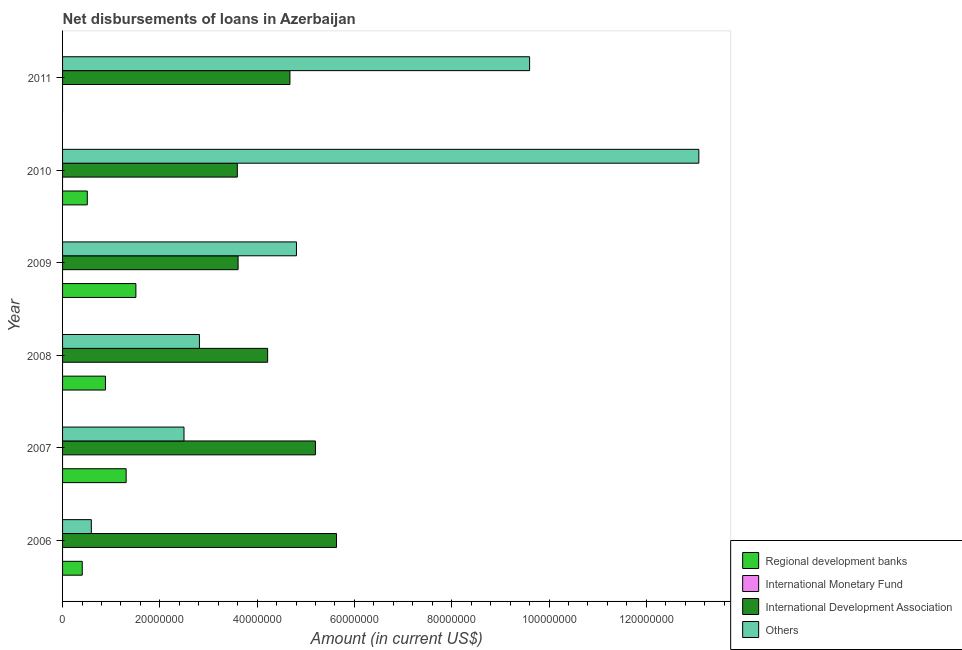How many different coloured bars are there?
Make the answer very short. 3. How many groups of bars are there?
Your answer should be compact. 6. Are the number of bars on each tick of the Y-axis equal?
Offer a terse response. No. In how many cases, is the number of bars for a given year not equal to the number of legend labels?
Keep it short and to the point. 6. What is the amount of loan disimbursed by regional development banks in 2006?
Provide a succinct answer. 4.04e+06. Across all years, what is the maximum amount of loan disimbursed by other organisations?
Provide a short and direct response. 1.31e+08. Across all years, what is the minimum amount of loan disimbursed by other organisations?
Provide a succinct answer. 5.91e+06. What is the total amount of loan disimbursed by regional development banks in the graph?
Keep it short and to the point. 4.61e+07. What is the difference between the amount of loan disimbursed by international development association in 2007 and that in 2011?
Make the answer very short. 5.24e+06. What is the difference between the amount of loan disimbursed by regional development banks in 2010 and the amount of loan disimbursed by international development association in 2011?
Provide a succinct answer. -4.17e+07. What is the average amount of loan disimbursed by other organisations per year?
Ensure brevity in your answer.  5.56e+07. In the year 2009, what is the difference between the amount of loan disimbursed by international development association and amount of loan disimbursed by other organisations?
Ensure brevity in your answer.  -1.20e+07. What is the ratio of the amount of loan disimbursed by other organisations in 2007 to that in 2011?
Your answer should be compact. 0.26. Is the amount of loan disimbursed by other organisations in 2006 less than that in 2007?
Offer a very short reply. Yes. Is the difference between the amount of loan disimbursed by international development association in 2006 and 2008 greater than the difference between the amount of loan disimbursed by regional development banks in 2006 and 2008?
Offer a very short reply. Yes. What is the difference between the highest and the second highest amount of loan disimbursed by international development association?
Make the answer very short. 4.33e+06. What is the difference between the highest and the lowest amount of loan disimbursed by other organisations?
Your answer should be very brief. 1.25e+08. Is it the case that in every year, the sum of the amount of loan disimbursed by regional development banks and amount of loan disimbursed by international monetary fund is greater than the amount of loan disimbursed by international development association?
Provide a succinct answer. No. How many years are there in the graph?
Provide a short and direct response. 6. What is the difference between two consecutive major ticks on the X-axis?
Your answer should be very brief. 2.00e+07. Does the graph contain any zero values?
Make the answer very short. Yes. Does the graph contain grids?
Offer a terse response. No. Where does the legend appear in the graph?
Keep it short and to the point. Bottom right. How many legend labels are there?
Ensure brevity in your answer.  4. What is the title of the graph?
Your response must be concise. Net disbursements of loans in Azerbaijan. Does "Industry" appear as one of the legend labels in the graph?
Provide a succinct answer. No. What is the label or title of the X-axis?
Ensure brevity in your answer.  Amount (in current US$). What is the label or title of the Y-axis?
Your answer should be compact. Year. What is the Amount (in current US$) in Regional development banks in 2006?
Keep it short and to the point. 4.04e+06. What is the Amount (in current US$) of International Development Association in 2006?
Offer a terse response. 5.63e+07. What is the Amount (in current US$) of Others in 2006?
Give a very brief answer. 5.91e+06. What is the Amount (in current US$) of Regional development banks in 2007?
Keep it short and to the point. 1.31e+07. What is the Amount (in current US$) in International Monetary Fund in 2007?
Provide a succinct answer. 0. What is the Amount (in current US$) in International Development Association in 2007?
Keep it short and to the point. 5.20e+07. What is the Amount (in current US$) in Others in 2007?
Your answer should be compact. 2.50e+07. What is the Amount (in current US$) of Regional development banks in 2008?
Offer a very short reply. 8.81e+06. What is the Amount (in current US$) of International Development Association in 2008?
Provide a short and direct response. 4.22e+07. What is the Amount (in current US$) in Others in 2008?
Provide a succinct answer. 2.81e+07. What is the Amount (in current US$) of Regional development banks in 2009?
Provide a succinct answer. 1.51e+07. What is the Amount (in current US$) in International Development Association in 2009?
Keep it short and to the point. 3.61e+07. What is the Amount (in current US$) in Others in 2009?
Provide a succinct answer. 4.81e+07. What is the Amount (in current US$) of Regional development banks in 2010?
Give a very brief answer. 5.08e+06. What is the Amount (in current US$) in International Development Association in 2010?
Your answer should be very brief. 3.59e+07. What is the Amount (in current US$) in Others in 2010?
Keep it short and to the point. 1.31e+08. What is the Amount (in current US$) in International Development Association in 2011?
Give a very brief answer. 4.67e+07. What is the Amount (in current US$) of Others in 2011?
Offer a terse response. 9.60e+07. Across all years, what is the maximum Amount (in current US$) in Regional development banks?
Provide a short and direct response. 1.51e+07. Across all years, what is the maximum Amount (in current US$) in International Development Association?
Make the answer very short. 5.63e+07. Across all years, what is the maximum Amount (in current US$) in Others?
Ensure brevity in your answer.  1.31e+08. Across all years, what is the minimum Amount (in current US$) in Regional development banks?
Keep it short and to the point. 0. Across all years, what is the minimum Amount (in current US$) of International Development Association?
Make the answer very short. 3.59e+07. Across all years, what is the minimum Amount (in current US$) in Others?
Ensure brevity in your answer.  5.91e+06. What is the total Amount (in current US$) in Regional development banks in the graph?
Provide a short and direct response. 4.61e+07. What is the total Amount (in current US$) of International Development Association in the graph?
Make the answer very short. 2.69e+08. What is the total Amount (in current US$) of Others in the graph?
Your answer should be compact. 3.34e+08. What is the difference between the Amount (in current US$) in Regional development banks in 2006 and that in 2007?
Ensure brevity in your answer.  -9.02e+06. What is the difference between the Amount (in current US$) of International Development Association in 2006 and that in 2007?
Your answer should be very brief. 4.33e+06. What is the difference between the Amount (in current US$) in Others in 2006 and that in 2007?
Ensure brevity in your answer.  -1.90e+07. What is the difference between the Amount (in current US$) of Regional development banks in 2006 and that in 2008?
Provide a short and direct response. -4.77e+06. What is the difference between the Amount (in current US$) of International Development Association in 2006 and that in 2008?
Your answer should be compact. 1.42e+07. What is the difference between the Amount (in current US$) in Others in 2006 and that in 2008?
Make the answer very short. -2.22e+07. What is the difference between the Amount (in current US$) of Regional development banks in 2006 and that in 2009?
Make the answer very short. -1.10e+07. What is the difference between the Amount (in current US$) of International Development Association in 2006 and that in 2009?
Give a very brief answer. 2.02e+07. What is the difference between the Amount (in current US$) of Others in 2006 and that in 2009?
Provide a succinct answer. -4.22e+07. What is the difference between the Amount (in current US$) of Regional development banks in 2006 and that in 2010?
Your answer should be compact. -1.04e+06. What is the difference between the Amount (in current US$) in International Development Association in 2006 and that in 2010?
Offer a very short reply. 2.04e+07. What is the difference between the Amount (in current US$) in Others in 2006 and that in 2010?
Provide a succinct answer. -1.25e+08. What is the difference between the Amount (in current US$) of International Development Association in 2006 and that in 2011?
Offer a terse response. 9.57e+06. What is the difference between the Amount (in current US$) of Others in 2006 and that in 2011?
Your answer should be compact. -9.01e+07. What is the difference between the Amount (in current US$) in Regional development banks in 2007 and that in 2008?
Offer a very short reply. 4.26e+06. What is the difference between the Amount (in current US$) of International Development Association in 2007 and that in 2008?
Your response must be concise. 9.82e+06. What is the difference between the Amount (in current US$) of Others in 2007 and that in 2008?
Your answer should be very brief. -3.17e+06. What is the difference between the Amount (in current US$) in Regional development banks in 2007 and that in 2009?
Provide a succinct answer. -2.00e+06. What is the difference between the Amount (in current US$) in International Development Association in 2007 and that in 2009?
Provide a succinct answer. 1.59e+07. What is the difference between the Amount (in current US$) in Others in 2007 and that in 2009?
Your answer should be very brief. -2.31e+07. What is the difference between the Amount (in current US$) of Regional development banks in 2007 and that in 2010?
Provide a succinct answer. 7.98e+06. What is the difference between the Amount (in current US$) of International Development Association in 2007 and that in 2010?
Keep it short and to the point. 1.61e+07. What is the difference between the Amount (in current US$) in Others in 2007 and that in 2010?
Your response must be concise. -1.06e+08. What is the difference between the Amount (in current US$) in International Development Association in 2007 and that in 2011?
Your answer should be compact. 5.24e+06. What is the difference between the Amount (in current US$) in Others in 2007 and that in 2011?
Give a very brief answer. -7.10e+07. What is the difference between the Amount (in current US$) in Regional development banks in 2008 and that in 2009?
Provide a short and direct response. -6.26e+06. What is the difference between the Amount (in current US$) in International Development Association in 2008 and that in 2009?
Your response must be concise. 6.08e+06. What is the difference between the Amount (in current US$) of Others in 2008 and that in 2009?
Offer a terse response. -1.99e+07. What is the difference between the Amount (in current US$) of Regional development banks in 2008 and that in 2010?
Offer a terse response. 3.73e+06. What is the difference between the Amount (in current US$) in International Development Association in 2008 and that in 2010?
Give a very brief answer. 6.23e+06. What is the difference between the Amount (in current US$) of Others in 2008 and that in 2010?
Make the answer very short. -1.03e+08. What is the difference between the Amount (in current US$) of International Development Association in 2008 and that in 2011?
Give a very brief answer. -4.58e+06. What is the difference between the Amount (in current US$) in Others in 2008 and that in 2011?
Keep it short and to the point. -6.79e+07. What is the difference between the Amount (in current US$) in Regional development banks in 2009 and that in 2010?
Make the answer very short. 9.99e+06. What is the difference between the Amount (in current US$) in International Development Association in 2009 and that in 2010?
Your response must be concise. 1.56e+05. What is the difference between the Amount (in current US$) of Others in 2009 and that in 2010?
Provide a short and direct response. -8.27e+07. What is the difference between the Amount (in current US$) in International Development Association in 2009 and that in 2011?
Give a very brief answer. -1.07e+07. What is the difference between the Amount (in current US$) of Others in 2009 and that in 2011?
Keep it short and to the point. -4.79e+07. What is the difference between the Amount (in current US$) of International Development Association in 2010 and that in 2011?
Keep it short and to the point. -1.08e+07. What is the difference between the Amount (in current US$) in Others in 2010 and that in 2011?
Keep it short and to the point. 3.48e+07. What is the difference between the Amount (in current US$) of Regional development banks in 2006 and the Amount (in current US$) of International Development Association in 2007?
Your answer should be compact. -4.79e+07. What is the difference between the Amount (in current US$) in Regional development banks in 2006 and the Amount (in current US$) in Others in 2007?
Keep it short and to the point. -2.09e+07. What is the difference between the Amount (in current US$) of International Development Association in 2006 and the Amount (in current US$) of Others in 2007?
Your answer should be very brief. 3.14e+07. What is the difference between the Amount (in current US$) of Regional development banks in 2006 and the Amount (in current US$) of International Development Association in 2008?
Make the answer very short. -3.81e+07. What is the difference between the Amount (in current US$) in Regional development banks in 2006 and the Amount (in current US$) in Others in 2008?
Offer a very short reply. -2.41e+07. What is the difference between the Amount (in current US$) in International Development Association in 2006 and the Amount (in current US$) in Others in 2008?
Provide a succinct answer. 2.82e+07. What is the difference between the Amount (in current US$) in Regional development banks in 2006 and the Amount (in current US$) in International Development Association in 2009?
Your answer should be very brief. -3.20e+07. What is the difference between the Amount (in current US$) of Regional development banks in 2006 and the Amount (in current US$) of Others in 2009?
Your response must be concise. -4.40e+07. What is the difference between the Amount (in current US$) of International Development Association in 2006 and the Amount (in current US$) of Others in 2009?
Provide a short and direct response. 8.23e+06. What is the difference between the Amount (in current US$) of Regional development banks in 2006 and the Amount (in current US$) of International Development Association in 2010?
Provide a short and direct response. -3.19e+07. What is the difference between the Amount (in current US$) in Regional development banks in 2006 and the Amount (in current US$) in Others in 2010?
Provide a short and direct response. -1.27e+08. What is the difference between the Amount (in current US$) in International Development Association in 2006 and the Amount (in current US$) in Others in 2010?
Keep it short and to the point. -7.45e+07. What is the difference between the Amount (in current US$) of Regional development banks in 2006 and the Amount (in current US$) of International Development Association in 2011?
Give a very brief answer. -4.27e+07. What is the difference between the Amount (in current US$) in Regional development banks in 2006 and the Amount (in current US$) in Others in 2011?
Provide a short and direct response. -9.20e+07. What is the difference between the Amount (in current US$) in International Development Association in 2006 and the Amount (in current US$) in Others in 2011?
Provide a succinct answer. -3.97e+07. What is the difference between the Amount (in current US$) of Regional development banks in 2007 and the Amount (in current US$) of International Development Association in 2008?
Offer a terse response. -2.91e+07. What is the difference between the Amount (in current US$) in Regional development banks in 2007 and the Amount (in current US$) in Others in 2008?
Make the answer very short. -1.51e+07. What is the difference between the Amount (in current US$) of International Development Association in 2007 and the Amount (in current US$) of Others in 2008?
Your answer should be very brief. 2.38e+07. What is the difference between the Amount (in current US$) in Regional development banks in 2007 and the Amount (in current US$) in International Development Association in 2009?
Ensure brevity in your answer.  -2.30e+07. What is the difference between the Amount (in current US$) in Regional development banks in 2007 and the Amount (in current US$) in Others in 2009?
Ensure brevity in your answer.  -3.50e+07. What is the difference between the Amount (in current US$) of International Development Association in 2007 and the Amount (in current US$) of Others in 2009?
Make the answer very short. 3.90e+06. What is the difference between the Amount (in current US$) of Regional development banks in 2007 and the Amount (in current US$) of International Development Association in 2010?
Provide a short and direct response. -2.29e+07. What is the difference between the Amount (in current US$) of Regional development banks in 2007 and the Amount (in current US$) of Others in 2010?
Offer a terse response. -1.18e+08. What is the difference between the Amount (in current US$) of International Development Association in 2007 and the Amount (in current US$) of Others in 2010?
Offer a very short reply. -7.88e+07. What is the difference between the Amount (in current US$) in Regional development banks in 2007 and the Amount (in current US$) in International Development Association in 2011?
Make the answer very short. -3.37e+07. What is the difference between the Amount (in current US$) in Regional development banks in 2007 and the Amount (in current US$) in Others in 2011?
Offer a terse response. -8.29e+07. What is the difference between the Amount (in current US$) of International Development Association in 2007 and the Amount (in current US$) of Others in 2011?
Give a very brief answer. -4.40e+07. What is the difference between the Amount (in current US$) in Regional development banks in 2008 and the Amount (in current US$) in International Development Association in 2009?
Your answer should be compact. -2.73e+07. What is the difference between the Amount (in current US$) of Regional development banks in 2008 and the Amount (in current US$) of Others in 2009?
Keep it short and to the point. -3.93e+07. What is the difference between the Amount (in current US$) in International Development Association in 2008 and the Amount (in current US$) in Others in 2009?
Make the answer very short. -5.92e+06. What is the difference between the Amount (in current US$) in Regional development banks in 2008 and the Amount (in current US$) in International Development Association in 2010?
Keep it short and to the point. -2.71e+07. What is the difference between the Amount (in current US$) in Regional development banks in 2008 and the Amount (in current US$) in Others in 2010?
Your answer should be compact. -1.22e+08. What is the difference between the Amount (in current US$) in International Development Association in 2008 and the Amount (in current US$) in Others in 2010?
Make the answer very short. -8.86e+07. What is the difference between the Amount (in current US$) of Regional development banks in 2008 and the Amount (in current US$) of International Development Association in 2011?
Make the answer very short. -3.79e+07. What is the difference between the Amount (in current US$) of Regional development banks in 2008 and the Amount (in current US$) of Others in 2011?
Offer a terse response. -8.72e+07. What is the difference between the Amount (in current US$) in International Development Association in 2008 and the Amount (in current US$) in Others in 2011?
Keep it short and to the point. -5.39e+07. What is the difference between the Amount (in current US$) in Regional development banks in 2009 and the Amount (in current US$) in International Development Association in 2010?
Offer a very short reply. -2.09e+07. What is the difference between the Amount (in current US$) of Regional development banks in 2009 and the Amount (in current US$) of Others in 2010?
Your response must be concise. -1.16e+08. What is the difference between the Amount (in current US$) in International Development Association in 2009 and the Amount (in current US$) in Others in 2010?
Provide a succinct answer. -9.47e+07. What is the difference between the Amount (in current US$) of Regional development banks in 2009 and the Amount (in current US$) of International Development Association in 2011?
Your answer should be compact. -3.17e+07. What is the difference between the Amount (in current US$) in Regional development banks in 2009 and the Amount (in current US$) in Others in 2011?
Offer a very short reply. -8.09e+07. What is the difference between the Amount (in current US$) of International Development Association in 2009 and the Amount (in current US$) of Others in 2011?
Provide a short and direct response. -5.99e+07. What is the difference between the Amount (in current US$) in Regional development banks in 2010 and the Amount (in current US$) in International Development Association in 2011?
Offer a terse response. -4.17e+07. What is the difference between the Amount (in current US$) in Regional development banks in 2010 and the Amount (in current US$) in Others in 2011?
Provide a succinct answer. -9.09e+07. What is the difference between the Amount (in current US$) of International Development Association in 2010 and the Amount (in current US$) of Others in 2011?
Offer a terse response. -6.01e+07. What is the average Amount (in current US$) in Regional development banks per year?
Ensure brevity in your answer.  7.68e+06. What is the average Amount (in current US$) in International Development Association per year?
Ensure brevity in your answer.  4.49e+07. What is the average Amount (in current US$) in Others per year?
Keep it short and to the point. 5.56e+07. In the year 2006, what is the difference between the Amount (in current US$) of Regional development banks and Amount (in current US$) of International Development Association?
Your answer should be very brief. -5.23e+07. In the year 2006, what is the difference between the Amount (in current US$) of Regional development banks and Amount (in current US$) of Others?
Your answer should be compact. -1.87e+06. In the year 2006, what is the difference between the Amount (in current US$) of International Development Association and Amount (in current US$) of Others?
Offer a very short reply. 5.04e+07. In the year 2007, what is the difference between the Amount (in current US$) in Regional development banks and Amount (in current US$) in International Development Association?
Offer a terse response. -3.89e+07. In the year 2007, what is the difference between the Amount (in current US$) in Regional development banks and Amount (in current US$) in Others?
Offer a terse response. -1.19e+07. In the year 2007, what is the difference between the Amount (in current US$) of International Development Association and Amount (in current US$) of Others?
Provide a succinct answer. 2.70e+07. In the year 2008, what is the difference between the Amount (in current US$) of Regional development banks and Amount (in current US$) of International Development Association?
Provide a succinct answer. -3.33e+07. In the year 2008, what is the difference between the Amount (in current US$) in Regional development banks and Amount (in current US$) in Others?
Ensure brevity in your answer.  -1.93e+07. In the year 2008, what is the difference between the Amount (in current US$) of International Development Association and Amount (in current US$) of Others?
Your response must be concise. 1.40e+07. In the year 2009, what is the difference between the Amount (in current US$) in Regional development banks and Amount (in current US$) in International Development Association?
Your answer should be very brief. -2.10e+07. In the year 2009, what is the difference between the Amount (in current US$) of Regional development banks and Amount (in current US$) of Others?
Make the answer very short. -3.30e+07. In the year 2009, what is the difference between the Amount (in current US$) in International Development Association and Amount (in current US$) in Others?
Make the answer very short. -1.20e+07. In the year 2010, what is the difference between the Amount (in current US$) in Regional development banks and Amount (in current US$) in International Development Association?
Your answer should be compact. -3.08e+07. In the year 2010, what is the difference between the Amount (in current US$) of Regional development banks and Amount (in current US$) of Others?
Your answer should be compact. -1.26e+08. In the year 2010, what is the difference between the Amount (in current US$) of International Development Association and Amount (in current US$) of Others?
Offer a very short reply. -9.49e+07. In the year 2011, what is the difference between the Amount (in current US$) of International Development Association and Amount (in current US$) of Others?
Provide a short and direct response. -4.93e+07. What is the ratio of the Amount (in current US$) in Regional development banks in 2006 to that in 2007?
Make the answer very short. 0.31. What is the ratio of the Amount (in current US$) of International Development Association in 2006 to that in 2007?
Give a very brief answer. 1.08. What is the ratio of the Amount (in current US$) of Others in 2006 to that in 2007?
Keep it short and to the point. 0.24. What is the ratio of the Amount (in current US$) in Regional development banks in 2006 to that in 2008?
Make the answer very short. 0.46. What is the ratio of the Amount (in current US$) of International Development Association in 2006 to that in 2008?
Provide a short and direct response. 1.34. What is the ratio of the Amount (in current US$) in Others in 2006 to that in 2008?
Your answer should be compact. 0.21. What is the ratio of the Amount (in current US$) in Regional development banks in 2006 to that in 2009?
Provide a short and direct response. 0.27. What is the ratio of the Amount (in current US$) in International Development Association in 2006 to that in 2009?
Your answer should be compact. 1.56. What is the ratio of the Amount (in current US$) of Others in 2006 to that in 2009?
Provide a succinct answer. 0.12. What is the ratio of the Amount (in current US$) of Regional development banks in 2006 to that in 2010?
Provide a short and direct response. 0.8. What is the ratio of the Amount (in current US$) in International Development Association in 2006 to that in 2010?
Provide a succinct answer. 1.57. What is the ratio of the Amount (in current US$) of Others in 2006 to that in 2010?
Provide a short and direct response. 0.05. What is the ratio of the Amount (in current US$) of International Development Association in 2006 to that in 2011?
Give a very brief answer. 1.2. What is the ratio of the Amount (in current US$) in Others in 2006 to that in 2011?
Provide a succinct answer. 0.06. What is the ratio of the Amount (in current US$) in Regional development banks in 2007 to that in 2008?
Ensure brevity in your answer.  1.48. What is the ratio of the Amount (in current US$) of International Development Association in 2007 to that in 2008?
Your response must be concise. 1.23. What is the ratio of the Amount (in current US$) of Others in 2007 to that in 2008?
Offer a very short reply. 0.89. What is the ratio of the Amount (in current US$) of Regional development banks in 2007 to that in 2009?
Ensure brevity in your answer.  0.87. What is the ratio of the Amount (in current US$) of International Development Association in 2007 to that in 2009?
Offer a terse response. 1.44. What is the ratio of the Amount (in current US$) of Others in 2007 to that in 2009?
Offer a terse response. 0.52. What is the ratio of the Amount (in current US$) in Regional development banks in 2007 to that in 2010?
Your response must be concise. 2.57. What is the ratio of the Amount (in current US$) of International Development Association in 2007 to that in 2010?
Ensure brevity in your answer.  1.45. What is the ratio of the Amount (in current US$) in Others in 2007 to that in 2010?
Provide a short and direct response. 0.19. What is the ratio of the Amount (in current US$) in International Development Association in 2007 to that in 2011?
Offer a terse response. 1.11. What is the ratio of the Amount (in current US$) in Others in 2007 to that in 2011?
Provide a short and direct response. 0.26. What is the ratio of the Amount (in current US$) in Regional development banks in 2008 to that in 2009?
Make the answer very short. 0.58. What is the ratio of the Amount (in current US$) of International Development Association in 2008 to that in 2009?
Ensure brevity in your answer.  1.17. What is the ratio of the Amount (in current US$) of Others in 2008 to that in 2009?
Provide a short and direct response. 0.59. What is the ratio of the Amount (in current US$) of Regional development banks in 2008 to that in 2010?
Offer a very short reply. 1.73. What is the ratio of the Amount (in current US$) of International Development Association in 2008 to that in 2010?
Your response must be concise. 1.17. What is the ratio of the Amount (in current US$) of Others in 2008 to that in 2010?
Offer a very short reply. 0.22. What is the ratio of the Amount (in current US$) of International Development Association in 2008 to that in 2011?
Ensure brevity in your answer.  0.9. What is the ratio of the Amount (in current US$) in Others in 2008 to that in 2011?
Make the answer very short. 0.29. What is the ratio of the Amount (in current US$) of Regional development banks in 2009 to that in 2010?
Give a very brief answer. 2.96. What is the ratio of the Amount (in current US$) in International Development Association in 2009 to that in 2010?
Offer a very short reply. 1. What is the ratio of the Amount (in current US$) in Others in 2009 to that in 2010?
Your answer should be compact. 0.37. What is the ratio of the Amount (in current US$) in International Development Association in 2009 to that in 2011?
Ensure brevity in your answer.  0.77. What is the ratio of the Amount (in current US$) of Others in 2009 to that in 2011?
Provide a succinct answer. 0.5. What is the ratio of the Amount (in current US$) in International Development Association in 2010 to that in 2011?
Your response must be concise. 0.77. What is the ratio of the Amount (in current US$) in Others in 2010 to that in 2011?
Keep it short and to the point. 1.36. What is the difference between the highest and the second highest Amount (in current US$) of Regional development banks?
Offer a terse response. 2.00e+06. What is the difference between the highest and the second highest Amount (in current US$) of International Development Association?
Your answer should be compact. 4.33e+06. What is the difference between the highest and the second highest Amount (in current US$) in Others?
Your answer should be compact. 3.48e+07. What is the difference between the highest and the lowest Amount (in current US$) in Regional development banks?
Your response must be concise. 1.51e+07. What is the difference between the highest and the lowest Amount (in current US$) in International Development Association?
Your answer should be compact. 2.04e+07. What is the difference between the highest and the lowest Amount (in current US$) of Others?
Provide a short and direct response. 1.25e+08. 